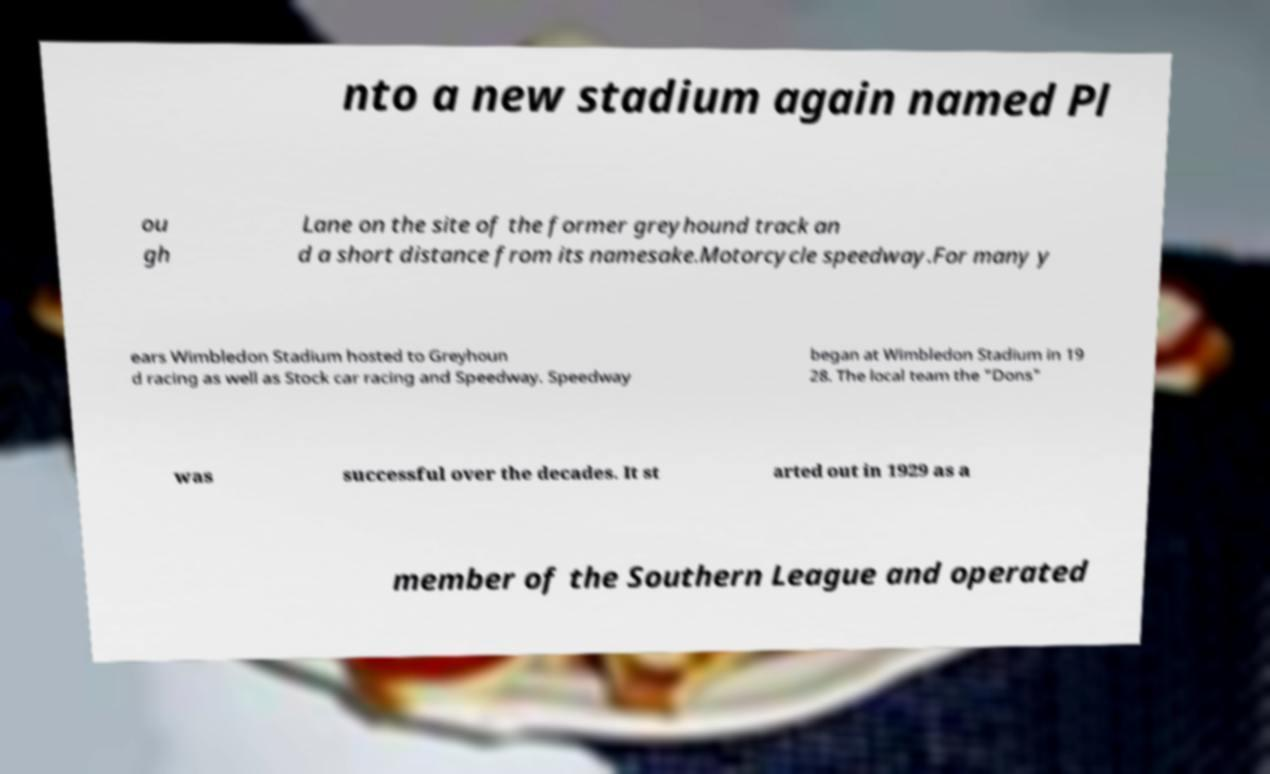Please read and relay the text visible in this image. What does it say? nto a new stadium again named Pl ou gh Lane on the site of the former greyhound track an d a short distance from its namesake.Motorcycle speedway.For many y ears Wimbledon Stadium hosted to Greyhoun d racing as well as Stock car racing and Speedway. Speedway began at Wimbledon Stadium in 19 28. The local team the "Dons" was successful over the decades. It st arted out in 1929 as a member of the Southern League and operated 